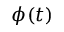Convert formula to latex. <formula><loc_0><loc_0><loc_500><loc_500>\phi ( t )</formula> 